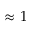<formula> <loc_0><loc_0><loc_500><loc_500>\approx 1</formula> 